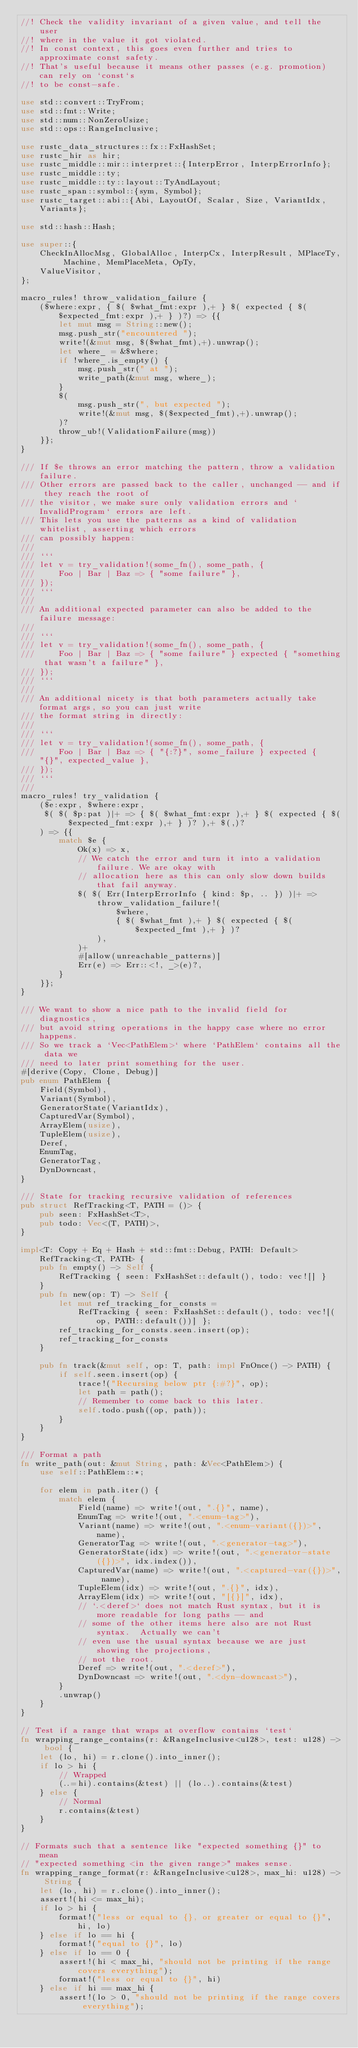<code> <loc_0><loc_0><loc_500><loc_500><_Rust_>//! Check the validity invariant of a given value, and tell the user
//! where in the value it got violated.
//! In const context, this goes even further and tries to approximate const safety.
//! That's useful because it means other passes (e.g. promotion) can rely on `const`s
//! to be const-safe.

use std::convert::TryFrom;
use std::fmt::Write;
use std::num::NonZeroUsize;
use std::ops::RangeInclusive;

use rustc_data_structures::fx::FxHashSet;
use rustc_hir as hir;
use rustc_middle::mir::interpret::{InterpError, InterpErrorInfo};
use rustc_middle::ty;
use rustc_middle::ty::layout::TyAndLayout;
use rustc_span::symbol::{sym, Symbol};
use rustc_target::abi::{Abi, LayoutOf, Scalar, Size, VariantIdx, Variants};

use std::hash::Hash;

use super::{
    CheckInAllocMsg, GlobalAlloc, InterpCx, InterpResult, MPlaceTy, Machine, MemPlaceMeta, OpTy,
    ValueVisitor,
};

macro_rules! throw_validation_failure {
    ($where:expr, { $( $what_fmt:expr ),+ } $( expected { $( $expected_fmt:expr ),+ } )?) => {{
        let mut msg = String::new();
        msg.push_str("encountered ");
        write!(&mut msg, $($what_fmt),+).unwrap();
        let where_ = &$where;
        if !where_.is_empty() {
            msg.push_str(" at ");
            write_path(&mut msg, where_);
        }
        $(
            msg.push_str(", but expected ");
            write!(&mut msg, $($expected_fmt),+).unwrap();
        )?
        throw_ub!(ValidationFailure(msg))
    }};
}

/// If $e throws an error matching the pattern, throw a validation failure.
/// Other errors are passed back to the caller, unchanged -- and if they reach the root of
/// the visitor, we make sure only validation errors and `InvalidProgram` errors are left.
/// This lets you use the patterns as a kind of validation whitelist, asserting which errors
/// can possibly happen:
///
/// ```
/// let v = try_validation!(some_fn(), some_path, {
///     Foo | Bar | Baz => { "some failure" },
/// });
/// ```
///
/// An additional expected parameter can also be added to the failure message:
///
/// ```
/// let v = try_validation!(some_fn(), some_path, {
///     Foo | Bar | Baz => { "some failure" } expected { "something that wasn't a failure" },
/// });
/// ```
///
/// An additional nicety is that both parameters actually take format args, so you can just write
/// the format string in directly:
///
/// ```
/// let v = try_validation!(some_fn(), some_path, {
///     Foo | Bar | Baz => { "{:?}", some_failure } expected { "{}", expected_value },
/// });
/// ```
///
macro_rules! try_validation {
    ($e:expr, $where:expr,
     $( $( $p:pat )|+ => { $( $what_fmt:expr ),+ } $( expected { $( $expected_fmt:expr ),+ } )? ),+ $(,)?
    ) => {{
        match $e {
            Ok(x) => x,
            // We catch the error and turn it into a validation failure. We are okay with
            // allocation here as this can only slow down builds that fail anyway.
            $( $( Err(InterpErrorInfo { kind: $p, .. }) )|+ =>
                throw_validation_failure!(
                    $where,
                    { $( $what_fmt ),+ } $( expected { $( $expected_fmt ),+ } )?
                ),
            )+
            #[allow(unreachable_patterns)]
            Err(e) => Err::<!, _>(e)?,
        }
    }};
}

/// We want to show a nice path to the invalid field for diagnostics,
/// but avoid string operations in the happy case where no error happens.
/// So we track a `Vec<PathElem>` where `PathElem` contains all the data we
/// need to later print something for the user.
#[derive(Copy, Clone, Debug)]
pub enum PathElem {
    Field(Symbol),
    Variant(Symbol),
    GeneratorState(VariantIdx),
    CapturedVar(Symbol),
    ArrayElem(usize),
    TupleElem(usize),
    Deref,
    EnumTag,
    GeneratorTag,
    DynDowncast,
}

/// State for tracking recursive validation of references
pub struct RefTracking<T, PATH = ()> {
    pub seen: FxHashSet<T>,
    pub todo: Vec<(T, PATH)>,
}

impl<T: Copy + Eq + Hash + std::fmt::Debug, PATH: Default> RefTracking<T, PATH> {
    pub fn empty() -> Self {
        RefTracking { seen: FxHashSet::default(), todo: vec![] }
    }
    pub fn new(op: T) -> Self {
        let mut ref_tracking_for_consts =
            RefTracking { seen: FxHashSet::default(), todo: vec![(op, PATH::default())] };
        ref_tracking_for_consts.seen.insert(op);
        ref_tracking_for_consts
    }

    pub fn track(&mut self, op: T, path: impl FnOnce() -> PATH) {
        if self.seen.insert(op) {
            trace!("Recursing below ptr {:#?}", op);
            let path = path();
            // Remember to come back to this later.
            self.todo.push((op, path));
        }
    }
}

/// Format a path
fn write_path(out: &mut String, path: &Vec<PathElem>) {
    use self::PathElem::*;

    for elem in path.iter() {
        match elem {
            Field(name) => write!(out, ".{}", name),
            EnumTag => write!(out, ".<enum-tag>"),
            Variant(name) => write!(out, ".<enum-variant({})>", name),
            GeneratorTag => write!(out, ".<generator-tag>"),
            GeneratorState(idx) => write!(out, ".<generator-state({})>", idx.index()),
            CapturedVar(name) => write!(out, ".<captured-var({})>", name),
            TupleElem(idx) => write!(out, ".{}", idx),
            ArrayElem(idx) => write!(out, "[{}]", idx),
            // `.<deref>` does not match Rust syntax, but it is more readable for long paths -- and
            // some of the other items here also are not Rust syntax.  Actually we can't
            // even use the usual syntax because we are just showing the projections,
            // not the root.
            Deref => write!(out, ".<deref>"),
            DynDowncast => write!(out, ".<dyn-downcast>"),
        }
        .unwrap()
    }
}

// Test if a range that wraps at overflow contains `test`
fn wrapping_range_contains(r: &RangeInclusive<u128>, test: u128) -> bool {
    let (lo, hi) = r.clone().into_inner();
    if lo > hi {
        // Wrapped
        (..=hi).contains(&test) || (lo..).contains(&test)
    } else {
        // Normal
        r.contains(&test)
    }
}

// Formats such that a sentence like "expected something {}" to mean
// "expected something <in the given range>" makes sense.
fn wrapping_range_format(r: &RangeInclusive<u128>, max_hi: u128) -> String {
    let (lo, hi) = r.clone().into_inner();
    assert!(hi <= max_hi);
    if lo > hi {
        format!("less or equal to {}, or greater or equal to {}", hi, lo)
    } else if lo == hi {
        format!("equal to {}", lo)
    } else if lo == 0 {
        assert!(hi < max_hi, "should not be printing if the range covers everything");
        format!("less or equal to {}", hi)
    } else if hi == max_hi {
        assert!(lo > 0, "should not be printing if the range covers everything");</code> 